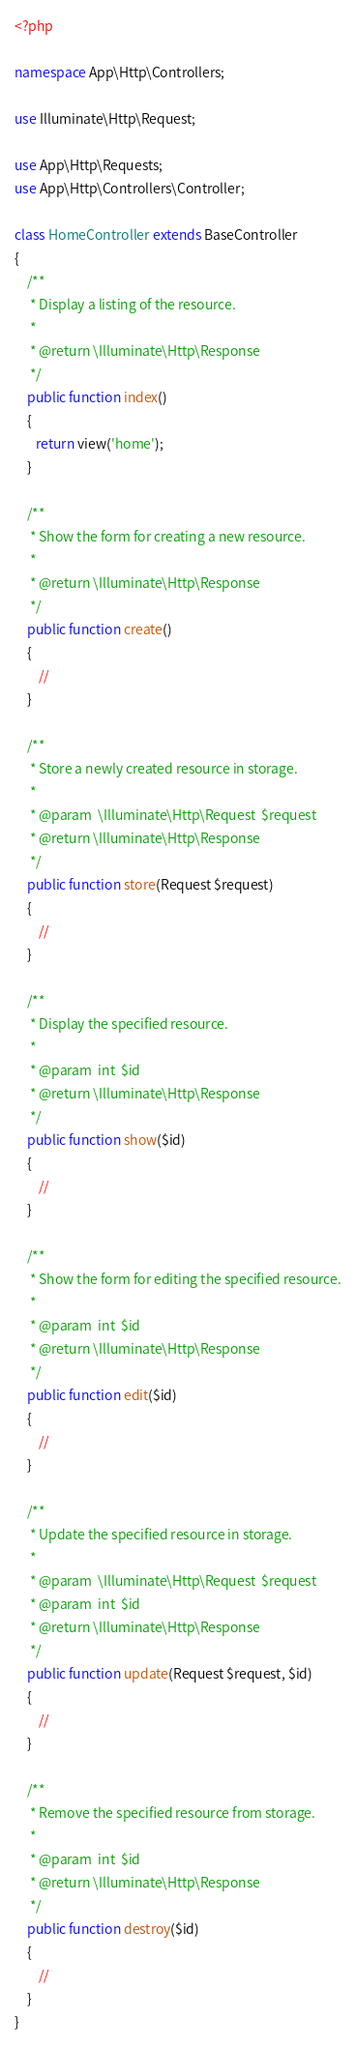Convert code to text. <code><loc_0><loc_0><loc_500><loc_500><_PHP_><?php

namespace App\Http\Controllers;

use Illuminate\Http\Request;

use App\Http\Requests;
use App\Http\Controllers\Controller;

class HomeController extends BaseController
{
    /**
     * Display a listing of the resource.
     *
     * @return \Illuminate\Http\Response
     */
    public function index()
    {
       return view('home');
    }

    /**
     * Show the form for creating a new resource.
     *
     * @return \Illuminate\Http\Response
     */
    public function create()
    {
        //
    }

    /**
     * Store a newly created resource in storage.
     *
     * @param  \Illuminate\Http\Request  $request
     * @return \Illuminate\Http\Response
     */
    public function store(Request $request)
    {
        //
    }

    /**
     * Display the specified resource.
     *
     * @param  int  $id
     * @return \Illuminate\Http\Response
     */
    public function show($id)
    {
        //
    }

    /**
     * Show the form for editing the specified resource.
     *
     * @param  int  $id
     * @return \Illuminate\Http\Response
     */
    public function edit($id)
    {
        //
    }

    /**
     * Update the specified resource in storage.
     *
     * @param  \Illuminate\Http\Request  $request
     * @param  int  $id
     * @return \Illuminate\Http\Response
     */
    public function update(Request $request, $id)
    {
        //
    }

    /**
     * Remove the specified resource from storage.
     *
     * @param  int  $id
     * @return \Illuminate\Http\Response
     */
    public function destroy($id)
    {
        //
    }
}
</code> 